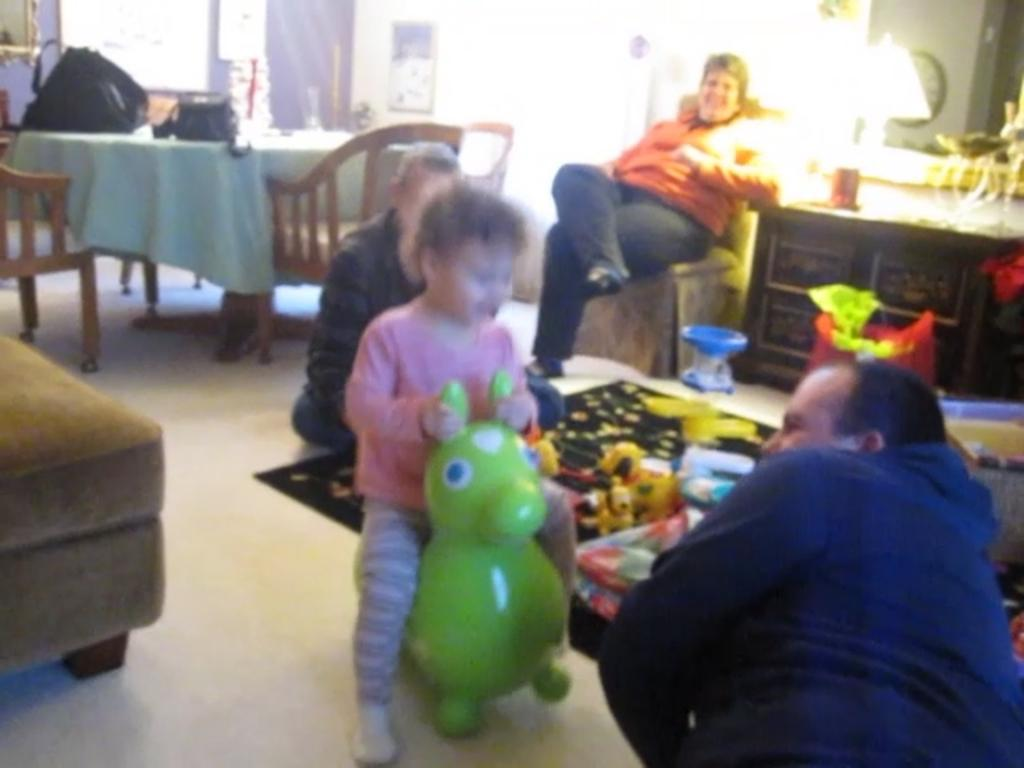How many people are sitting on the floor in the image? There are three persons sitting on the floor in the image. How many people are sitting on a chair in the image? There is one person sitting on a chair in the image. What type of powder is being used by the person sitting on the chair? There is no mention of powder in the image, so it cannot be determined if any powder is being used. 